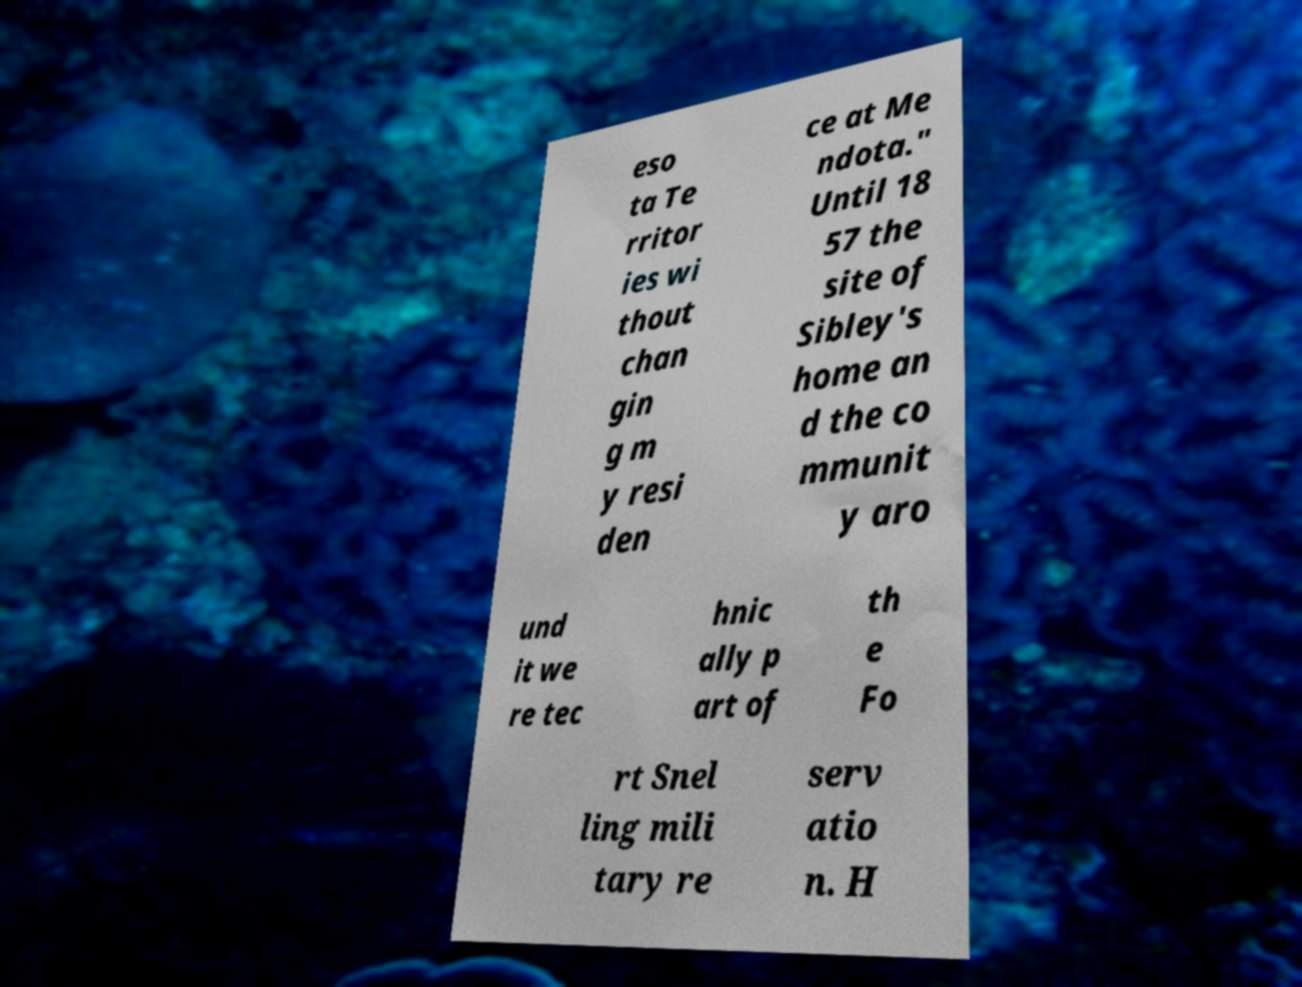Could you assist in decoding the text presented in this image and type it out clearly? eso ta Te rritor ies wi thout chan gin g m y resi den ce at Me ndota." Until 18 57 the site of Sibley's home an d the co mmunit y aro und it we re tec hnic ally p art of th e Fo rt Snel ling mili tary re serv atio n. H 